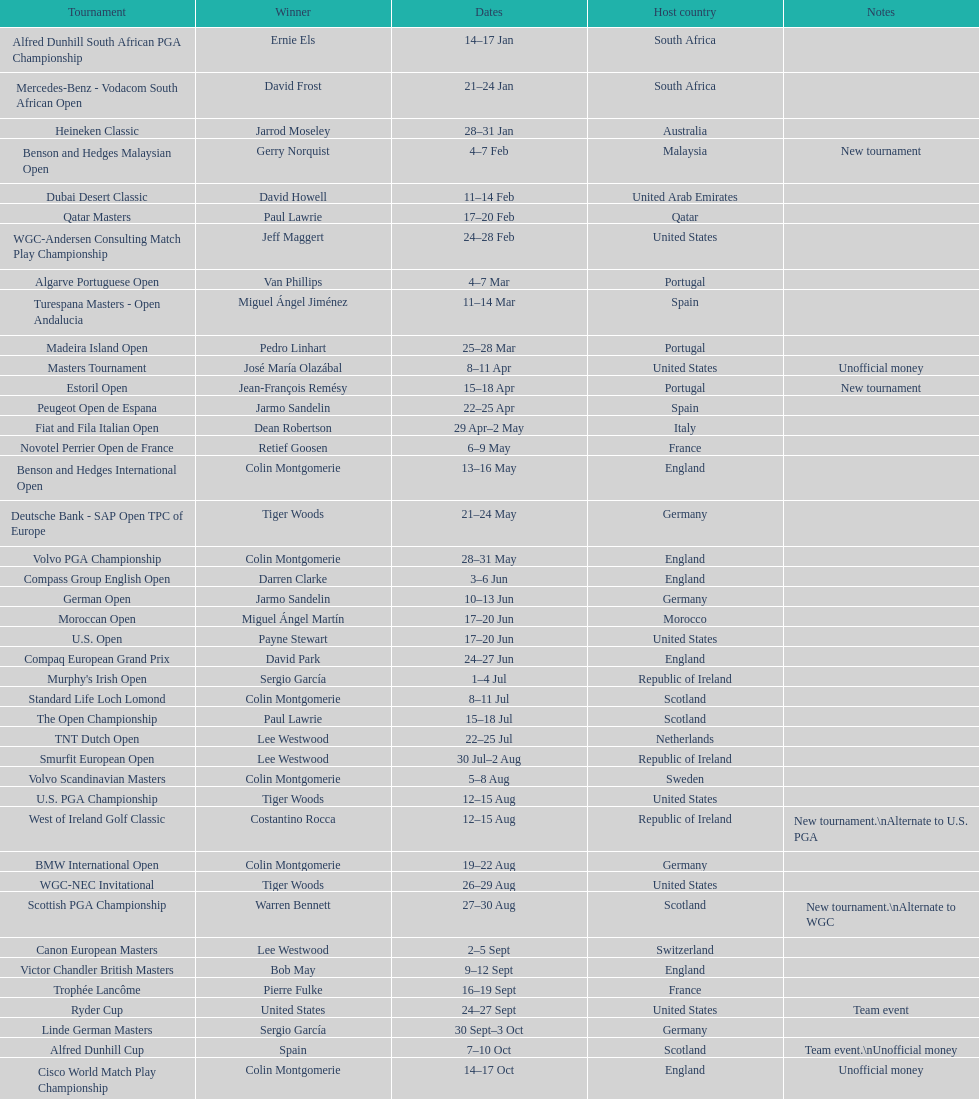What was the country listed the first time there was a new tournament? Malaysia. 